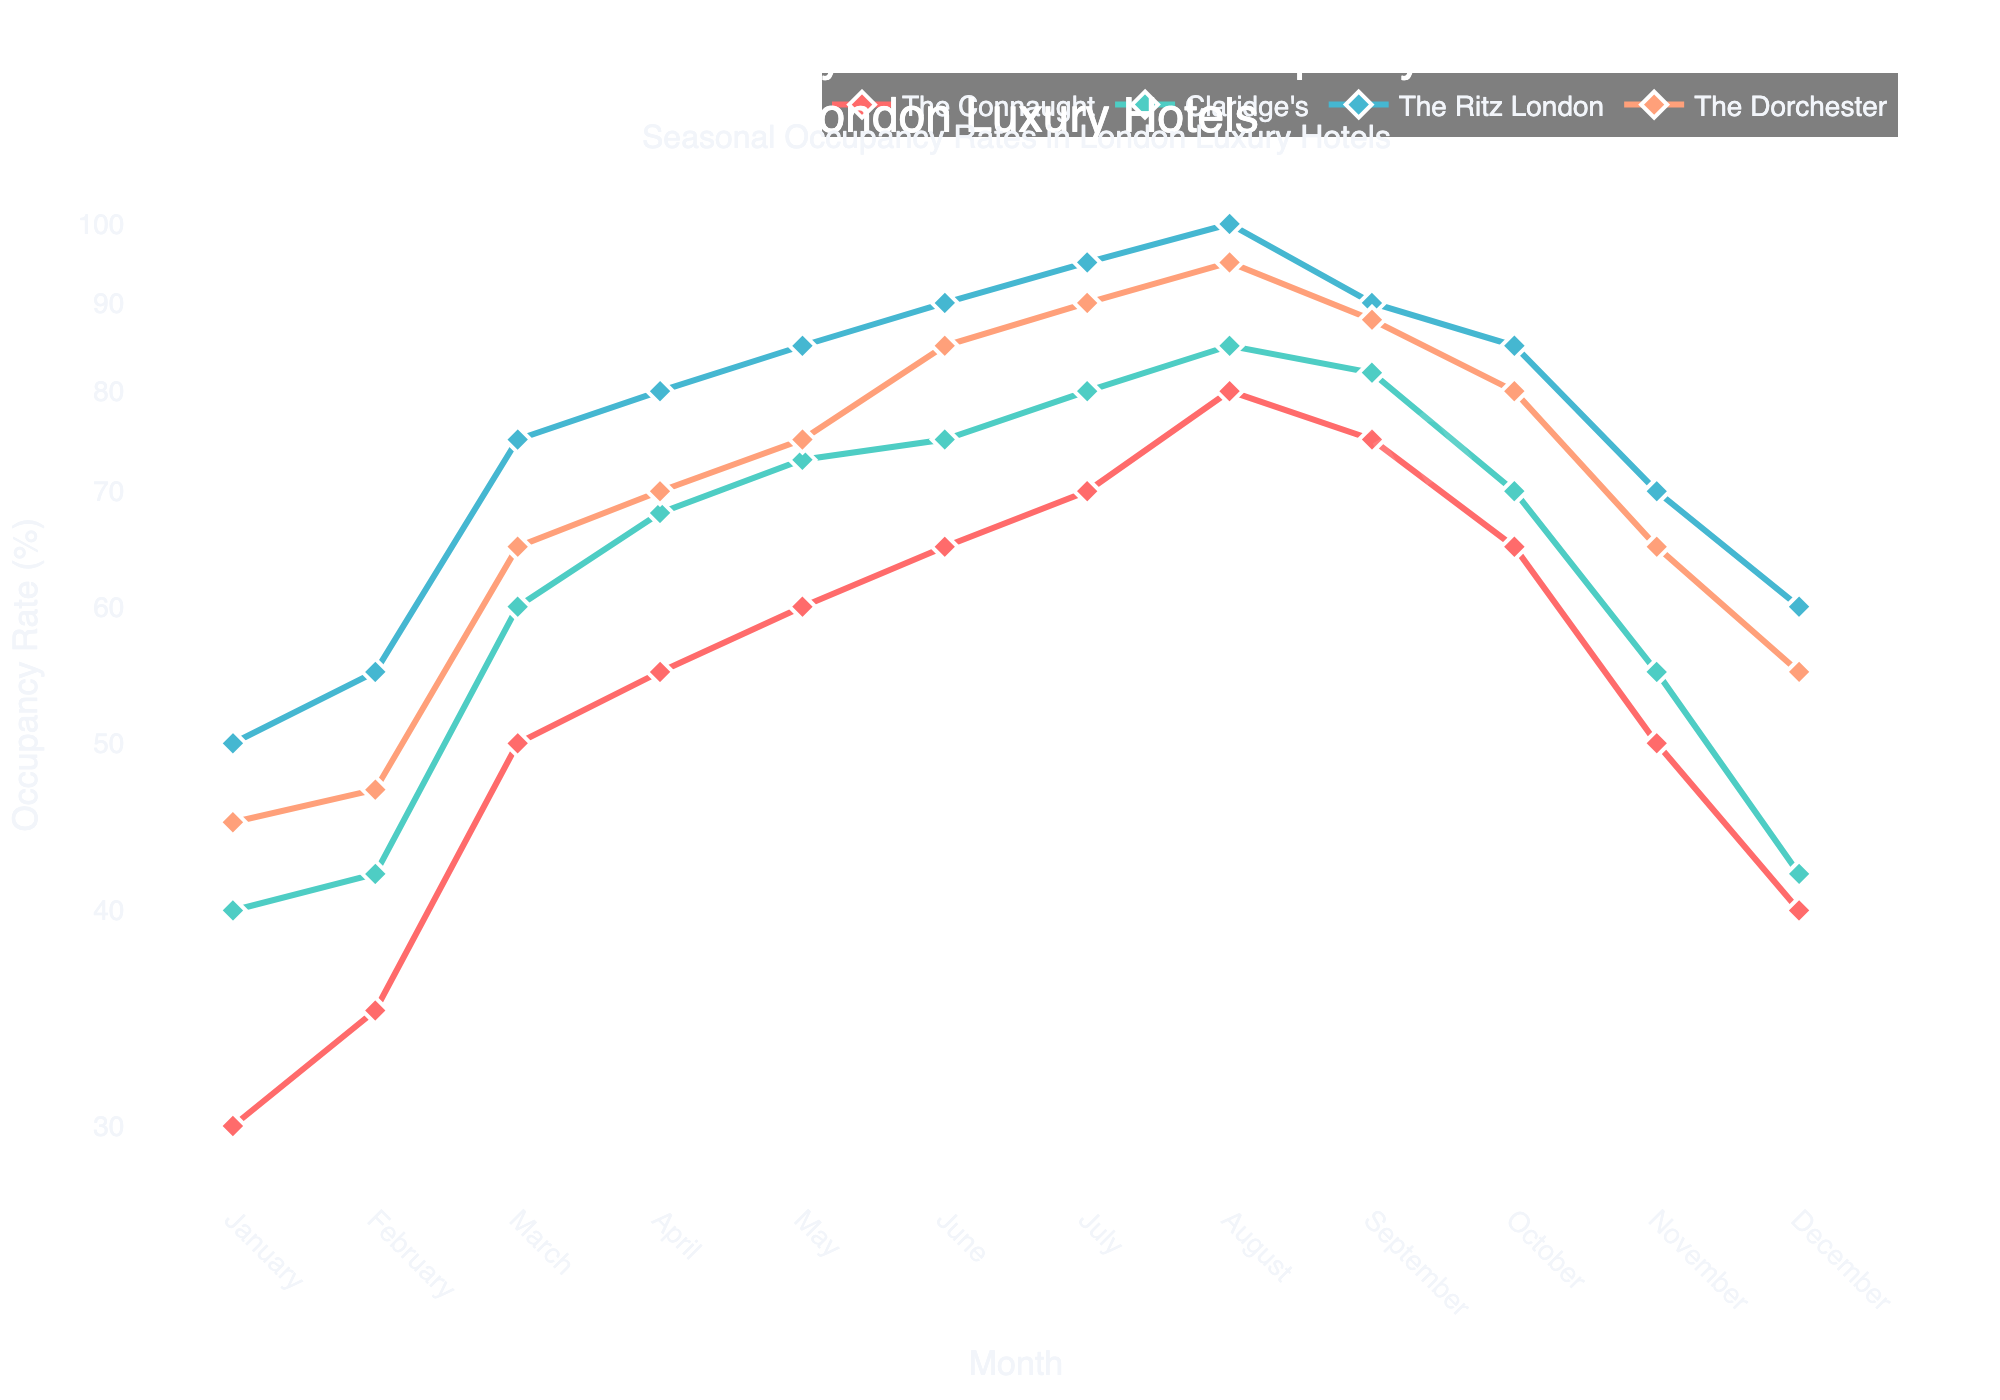Which hotel has the highest occupancy rate in July? The plot shows different occupancy rates for each hotel, and in July, we see that The Ritz London has the highest value because its curve is the highest on the y-axis among all the hotels.
Answer: The Ritz London What is the title of the figure? The title is displayed at the top of the figure, and it reads "Comparative Analysis of Seasonal Occupancy Rates in London Luxury Hotels".
Answer: Comparative Analysis of Seasonal Occupancy Rates in London Luxury Hotels How does the occupancy rate of The Connaught in January compare to its rate in August? By viewing the plot, we can see the occupancy rate for The Connaught in January is lower than in August. In January, the rate is 30%, whereas in August, it rises to 80%.
Answer: August has a higher rate Which month shows the least occupancy rate for Claridge's, and what is the rate? The minimum value for Claridge's occurs in January and December where both months show an occupancy rate of 40%.
Answer: January and December; 40% Throughout the year, which hotel shows the smallest variability in occupancy rates? To determine this, we look for the hotel with the flattest curve, implying less fluctuation. The Connaught shows the most gradual change compared to the others.
Answer: The Connaught When was The Ritz London’s occupancy rate exactly 90%? Observing the graph, The Ritz London's occupancy rate hits 90% in June.
Answer: June How much higher is The Dorchester's occupancy rate in July compared to November? By checking the plot, The Dorchester’s rate in July is 90%, and in November it is 65%. The difference is 90% - 65% = 25%.
Answer: 25% What is the average occupancy rate for The Connaught over the year? Adding the monthly rates for The Connaught (30 + 35 + 50 + 55 + 60 + 65 + 70 + 80 + 75 + 65 + 50 + 40) and dividing by 12 gives (675/12) = 56.25%.
Answer: 56.25% Which month has the highest overall occupancy rate across all hotels? The month with the highest rates across all hotels can be identified by finding where the culmination of lines is the highest on the y-axis. August appears to have the highest overall rates since all hotels peak around this month.
Answer: August What is the trend observed for The Dorchester's occupancy rate from April to August? The trend for The Dorchester from April to August is increasing. Its occupancy rate goes from 70% in April, rising consistently to 95% in August.
Answer: Increasing 